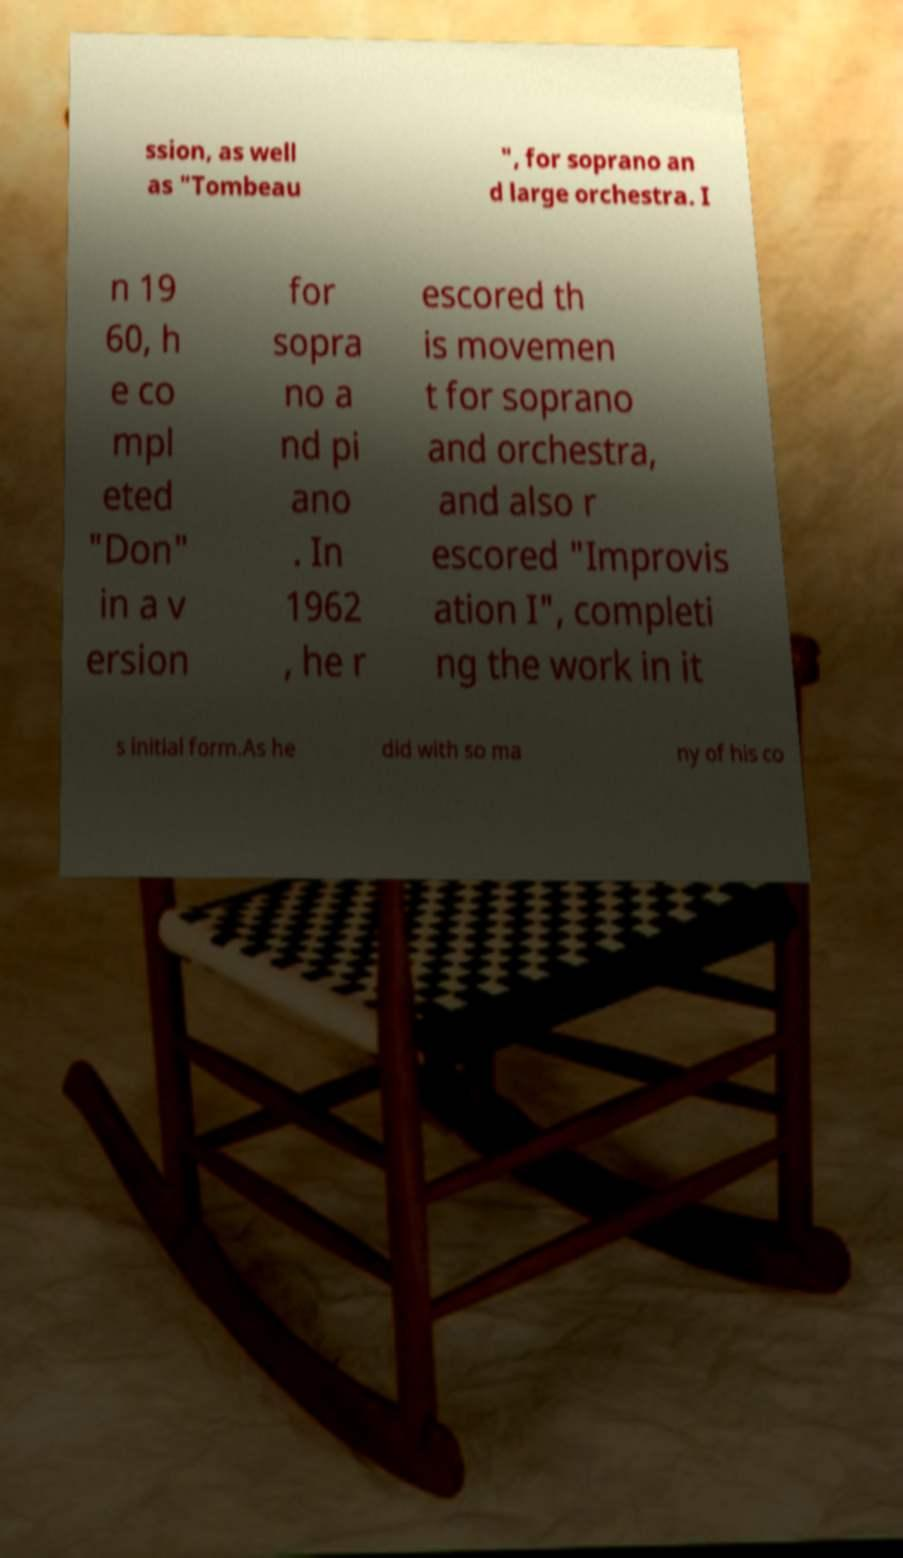I need the written content from this picture converted into text. Can you do that? ssion, as well as "Tombeau ", for soprano an d large orchestra. I n 19 60, h e co mpl eted "Don" in a v ersion for sopra no a nd pi ano . In 1962 , he r escored th is movemen t for soprano and orchestra, and also r escored "Improvis ation I", completi ng the work in it s initial form.As he did with so ma ny of his co 